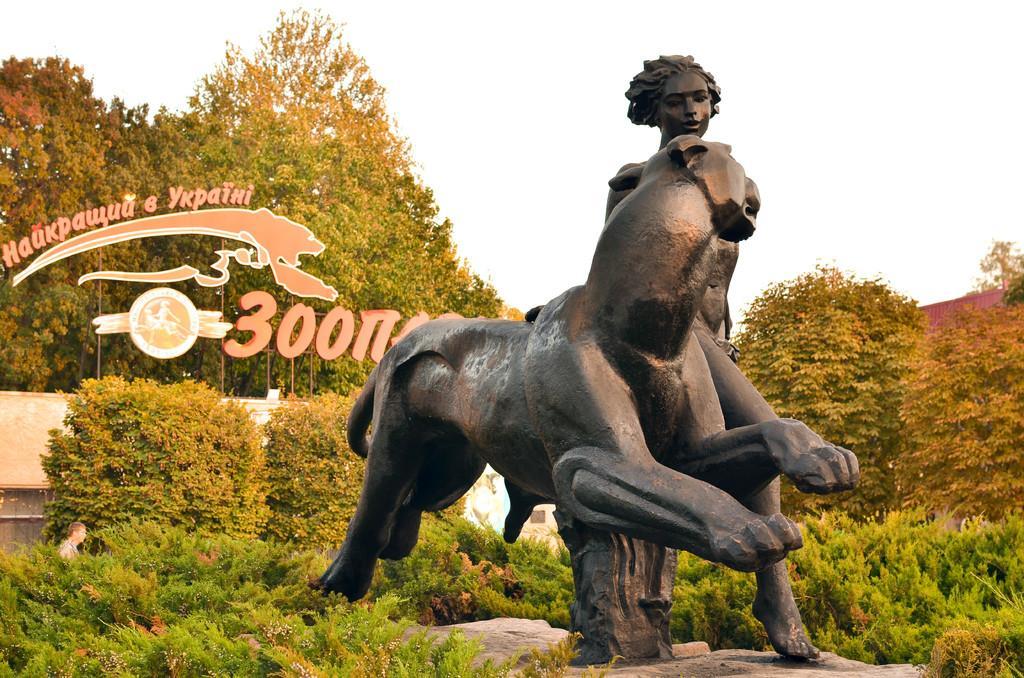How would you summarize this image in a sentence or two? In this image we can see the statue. We can also see the text with the logo. Image also consists of trees, plants and also a person in the background. Sky is also visible. 